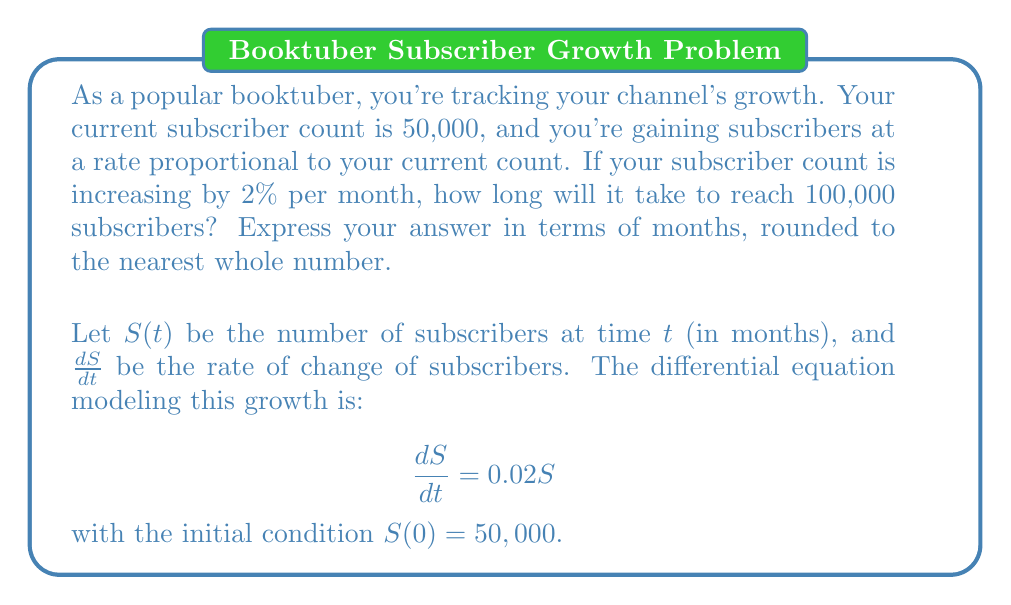Teach me how to tackle this problem. To solve this problem, we'll use the following steps:

1) The given differential equation is separable. Let's separate variables:

   $$\frac{dS}{S} = 0.02dt$$

2) Integrate both sides:

   $$\int \frac{dS}{S} = \int 0.02dt$$

   $$\ln|S| = 0.02t + C$$

3) Apply the initial condition $S(0) = 50,000$ to find $C$:

   $$\ln(50,000) = C$$

4) Substitute back into the general solution:

   $$\ln|S| = 0.02t + \ln(50,000)$$

5) Exponentiate both sides:

   $$S = 50,000e^{0.02t}$$

6) We want to find $t$ when $S = 100,000$. Substitute these values:

   $$100,000 = 50,000e^{0.02t}$$

7) Divide both sides by 50,000:

   $$2 = e^{0.02t}$$

8) Take the natural log of both sides:

   $$\ln(2) = 0.02t$$

9) Solve for $t$:

   $$t = \frac{\ln(2)}{0.02} \approx 34.66$$

10) Round to the nearest whole number:

    $$t \approx 35$$

Therefore, it will take approximately 35 months to reach 100,000 subscribers.
Answer: 35 months 